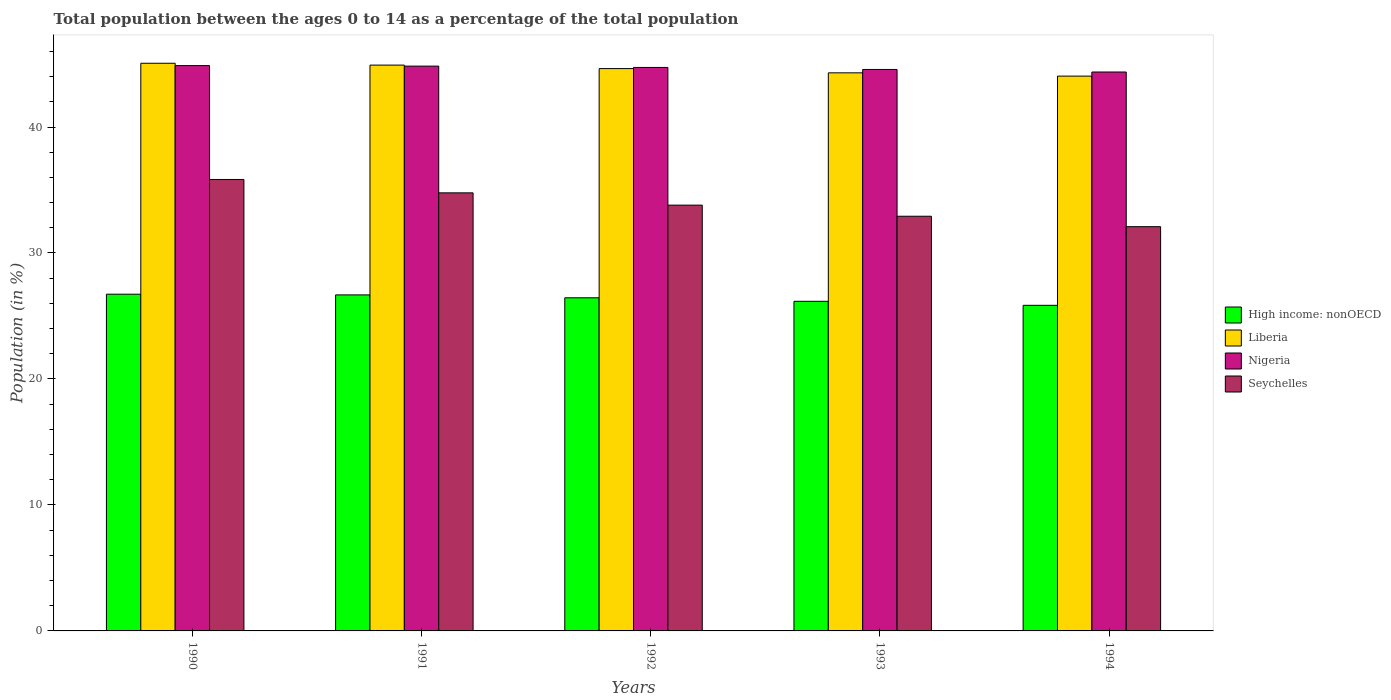How many groups of bars are there?
Keep it short and to the point. 5. Are the number of bars per tick equal to the number of legend labels?
Give a very brief answer. Yes. In how many cases, is the number of bars for a given year not equal to the number of legend labels?
Ensure brevity in your answer.  0. What is the percentage of the population ages 0 to 14 in High income: nonOECD in 1991?
Your answer should be very brief. 26.67. Across all years, what is the maximum percentage of the population ages 0 to 14 in Nigeria?
Ensure brevity in your answer.  44.88. Across all years, what is the minimum percentage of the population ages 0 to 14 in Seychelles?
Provide a succinct answer. 32.09. What is the total percentage of the population ages 0 to 14 in Liberia in the graph?
Your response must be concise. 222.96. What is the difference between the percentage of the population ages 0 to 14 in Seychelles in 1991 and that in 1993?
Offer a terse response. 1.86. What is the difference between the percentage of the population ages 0 to 14 in Seychelles in 1993 and the percentage of the population ages 0 to 14 in High income: nonOECD in 1990?
Ensure brevity in your answer.  6.19. What is the average percentage of the population ages 0 to 14 in Nigeria per year?
Your answer should be compact. 44.68. In the year 1993, what is the difference between the percentage of the population ages 0 to 14 in High income: nonOECD and percentage of the population ages 0 to 14 in Nigeria?
Make the answer very short. -18.4. In how many years, is the percentage of the population ages 0 to 14 in Seychelles greater than 12?
Offer a terse response. 5. What is the ratio of the percentage of the population ages 0 to 14 in Nigeria in 1991 to that in 1994?
Make the answer very short. 1.01. Is the percentage of the population ages 0 to 14 in Nigeria in 1990 less than that in 1993?
Your answer should be compact. No. Is the difference between the percentage of the population ages 0 to 14 in High income: nonOECD in 1991 and 1993 greater than the difference between the percentage of the population ages 0 to 14 in Nigeria in 1991 and 1993?
Offer a terse response. Yes. What is the difference between the highest and the second highest percentage of the population ages 0 to 14 in Seychelles?
Your answer should be very brief. 1.06. What is the difference between the highest and the lowest percentage of the population ages 0 to 14 in High income: nonOECD?
Make the answer very short. 0.88. What does the 3rd bar from the left in 1990 represents?
Your answer should be very brief. Nigeria. What does the 3rd bar from the right in 1994 represents?
Offer a terse response. Liberia. Are all the bars in the graph horizontal?
Make the answer very short. No. What is the difference between two consecutive major ticks on the Y-axis?
Ensure brevity in your answer.  10. Does the graph contain any zero values?
Your answer should be compact. No. Where does the legend appear in the graph?
Your response must be concise. Center right. What is the title of the graph?
Your response must be concise. Total population between the ages 0 to 14 as a percentage of the total population. Does "Upper middle income" appear as one of the legend labels in the graph?
Offer a very short reply. No. What is the label or title of the X-axis?
Provide a short and direct response. Years. What is the Population (in %) in High income: nonOECD in 1990?
Your answer should be compact. 26.73. What is the Population (in %) of Liberia in 1990?
Your answer should be compact. 45.06. What is the Population (in %) of Nigeria in 1990?
Your answer should be compact. 44.88. What is the Population (in %) in Seychelles in 1990?
Offer a terse response. 35.84. What is the Population (in %) of High income: nonOECD in 1991?
Give a very brief answer. 26.67. What is the Population (in %) of Liberia in 1991?
Offer a terse response. 44.92. What is the Population (in %) in Nigeria in 1991?
Your answer should be compact. 44.83. What is the Population (in %) in Seychelles in 1991?
Make the answer very short. 34.77. What is the Population (in %) in High income: nonOECD in 1992?
Offer a terse response. 26.44. What is the Population (in %) in Liberia in 1992?
Your answer should be compact. 44.64. What is the Population (in %) in Nigeria in 1992?
Your answer should be compact. 44.73. What is the Population (in %) in Seychelles in 1992?
Ensure brevity in your answer.  33.8. What is the Population (in %) in High income: nonOECD in 1993?
Make the answer very short. 26.16. What is the Population (in %) in Liberia in 1993?
Keep it short and to the point. 44.3. What is the Population (in %) in Nigeria in 1993?
Your response must be concise. 44.57. What is the Population (in %) in Seychelles in 1993?
Give a very brief answer. 32.92. What is the Population (in %) of High income: nonOECD in 1994?
Offer a very short reply. 25.85. What is the Population (in %) of Liberia in 1994?
Offer a terse response. 44.04. What is the Population (in %) of Nigeria in 1994?
Your answer should be compact. 44.37. What is the Population (in %) in Seychelles in 1994?
Provide a short and direct response. 32.09. Across all years, what is the maximum Population (in %) in High income: nonOECD?
Offer a very short reply. 26.73. Across all years, what is the maximum Population (in %) in Liberia?
Offer a very short reply. 45.06. Across all years, what is the maximum Population (in %) in Nigeria?
Offer a very short reply. 44.88. Across all years, what is the maximum Population (in %) of Seychelles?
Your response must be concise. 35.84. Across all years, what is the minimum Population (in %) in High income: nonOECD?
Offer a very short reply. 25.85. Across all years, what is the minimum Population (in %) of Liberia?
Provide a succinct answer. 44.04. Across all years, what is the minimum Population (in %) of Nigeria?
Provide a short and direct response. 44.37. Across all years, what is the minimum Population (in %) in Seychelles?
Offer a terse response. 32.09. What is the total Population (in %) of High income: nonOECD in the graph?
Offer a very short reply. 131.86. What is the total Population (in %) of Liberia in the graph?
Give a very brief answer. 222.96. What is the total Population (in %) of Nigeria in the graph?
Your answer should be very brief. 223.38. What is the total Population (in %) in Seychelles in the graph?
Offer a terse response. 169.42. What is the difference between the Population (in %) of High income: nonOECD in 1990 and that in 1991?
Provide a short and direct response. 0.06. What is the difference between the Population (in %) of Liberia in 1990 and that in 1991?
Your answer should be compact. 0.15. What is the difference between the Population (in %) in Nigeria in 1990 and that in 1991?
Your response must be concise. 0.04. What is the difference between the Population (in %) of Seychelles in 1990 and that in 1991?
Give a very brief answer. 1.06. What is the difference between the Population (in %) of High income: nonOECD in 1990 and that in 1992?
Your response must be concise. 0.29. What is the difference between the Population (in %) in Liberia in 1990 and that in 1992?
Give a very brief answer. 0.42. What is the difference between the Population (in %) in Nigeria in 1990 and that in 1992?
Provide a short and direct response. 0.15. What is the difference between the Population (in %) of Seychelles in 1990 and that in 1992?
Keep it short and to the point. 2.04. What is the difference between the Population (in %) in High income: nonOECD in 1990 and that in 1993?
Your answer should be very brief. 0.56. What is the difference between the Population (in %) of Liberia in 1990 and that in 1993?
Ensure brevity in your answer.  0.76. What is the difference between the Population (in %) in Nigeria in 1990 and that in 1993?
Ensure brevity in your answer.  0.31. What is the difference between the Population (in %) of Seychelles in 1990 and that in 1993?
Offer a very short reply. 2.92. What is the difference between the Population (in %) in High income: nonOECD in 1990 and that in 1994?
Give a very brief answer. 0.88. What is the difference between the Population (in %) in Liberia in 1990 and that in 1994?
Give a very brief answer. 1.02. What is the difference between the Population (in %) in Nigeria in 1990 and that in 1994?
Offer a terse response. 0.51. What is the difference between the Population (in %) in Seychelles in 1990 and that in 1994?
Keep it short and to the point. 3.75. What is the difference between the Population (in %) of High income: nonOECD in 1991 and that in 1992?
Give a very brief answer. 0.23. What is the difference between the Population (in %) of Liberia in 1991 and that in 1992?
Your response must be concise. 0.28. What is the difference between the Population (in %) in Nigeria in 1991 and that in 1992?
Offer a terse response. 0.11. What is the difference between the Population (in %) of Seychelles in 1991 and that in 1992?
Your answer should be compact. 0.97. What is the difference between the Population (in %) of High income: nonOECD in 1991 and that in 1993?
Provide a succinct answer. 0.51. What is the difference between the Population (in %) of Liberia in 1991 and that in 1993?
Offer a very short reply. 0.61. What is the difference between the Population (in %) in Nigeria in 1991 and that in 1993?
Your response must be concise. 0.27. What is the difference between the Population (in %) in Seychelles in 1991 and that in 1993?
Ensure brevity in your answer.  1.86. What is the difference between the Population (in %) in High income: nonOECD in 1991 and that in 1994?
Offer a terse response. 0.83. What is the difference between the Population (in %) in Liberia in 1991 and that in 1994?
Provide a short and direct response. 0.87. What is the difference between the Population (in %) in Nigeria in 1991 and that in 1994?
Your answer should be compact. 0.47. What is the difference between the Population (in %) in Seychelles in 1991 and that in 1994?
Your response must be concise. 2.68. What is the difference between the Population (in %) in High income: nonOECD in 1992 and that in 1993?
Your answer should be compact. 0.28. What is the difference between the Population (in %) of Liberia in 1992 and that in 1993?
Provide a succinct answer. 0.34. What is the difference between the Population (in %) in Nigeria in 1992 and that in 1993?
Provide a short and direct response. 0.16. What is the difference between the Population (in %) in Seychelles in 1992 and that in 1993?
Provide a short and direct response. 0.88. What is the difference between the Population (in %) of High income: nonOECD in 1992 and that in 1994?
Keep it short and to the point. 0.6. What is the difference between the Population (in %) of Liberia in 1992 and that in 1994?
Make the answer very short. 0.6. What is the difference between the Population (in %) in Nigeria in 1992 and that in 1994?
Ensure brevity in your answer.  0.36. What is the difference between the Population (in %) in Seychelles in 1992 and that in 1994?
Make the answer very short. 1.71. What is the difference between the Population (in %) of High income: nonOECD in 1993 and that in 1994?
Provide a succinct answer. 0.32. What is the difference between the Population (in %) in Liberia in 1993 and that in 1994?
Your answer should be very brief. 0.26. What is the difference between the Population (in %) of Nigeria in 1993 and that in 1994?
Your answer should be very brief. 0.2. What is the difference between the Population (in %) of Seychelles in 1993 and that in 1994?
Your response must be concise. 0.83. What is the difference between the Population (in %) of High income: nonOECD in 1990 and the Population (in %) of Liberia in 1991?
Provide a short and direct response. -18.19. What is the difference between the Population (in %) of High income: nonOECD in 1990 and the Population (in %) of Nigeria in 1991?
Provide a short and direct response. -18.11. What is the difference between the Population (in %) of High income: nonOECD in 1990 and the Population (in %) of Seychelles in 1991?
Keep it short and to the point. -8.04. What is the difference between the Population (in %) in Liberia in 1990 and the Population (in %) in Nigeria in 1991?
Offer a very short reply. 0.23. What is the difference between the Population (in %) in Liberia in 1990 and the Population (in %) in Seychelles in 1991?
Make the answer very short. 10.29. What is the difference between the Population (in %) of Nigeria in 1990 and the Population (in %) of Seychelles in 1991?
Your answer should be very brief. 10.1. What is the difference between the Population (in %) in High income: nonOECD in 1990 and the Population (in %) in Liberia in 1992?
Keep it short and to the point. -17.91. What is the difference between the Population (in %) in High income: nonOECD in 1990 and the Population (in %) in Nigeria in 1992?
Provide a short and direct response. -18. What is the difference between the Population (in %) of High income: nonOECD in 1990 and the Population (in %) of Seychelles in 1992?
Your response must be concise. -7.07. What is the difference between the Population (in %) in Liberia in 1990 and the Population (in %) in Nigeria in 1992?
Provide a short and direct response. 0.33. What is the difference between the Population (in %) of Liberia in 1990 and the Population (in %) of Seychelles in 1992?
Your answer should be very brief. 11.26. What is the difference between the Population (in %) in Nigeria in 1990 and the Population (in %) in Seychelles in 1992?
Provide a succinct answer. 11.08. What is the difference between the Population (in %) of High income: nonOECD in 1990 and the Population (in %) of Liberia in 1993?
Offer a terse response. -17.57. What is the difference between the Population (in %) in High income: nonOECD in 1990 and the Population (in %) in Nigeria in 1993?
Provide a succinct answer. -17.84. What is the difference between the Population (in %) of High income: nonOECD in 1990 and the Population (in %) of Seychelles in 1993?
Your answer should be compact. -6.19. What is the difference between the Population (in %) of Liberia in 1990 and the Population (in %) of Nigeria in 1993?
Provide a succinct answer. 0.49. What is the difference between the Population (in %) in Liberia in 1990 and the Population (in %) in Seychelles in 1993?
Keep it short and to the point. 12.14. What is the difference between the Population (in %) of Nigeria in 1990 and the Population (in %) of Seychelles in 1993?
Your answer should be very brief. 11.96. What is the difference between the Population (in %) of High income: nonOECD in 1990 and the Population (in %) of Liberia in 1994?
Make the answer very short. -17.31. What is the difference between the Population (in %) in High income: nonOECD in 1990 and the Population (in %) in Nigeria in 1994?
Provide a short and direct response. -17.64. What is the difference between the Population (in %) in High income: nonOECD in 1990 and the Population (in %) in Seychelles in 1994?
Your answer should be very brief. -5.36. What is the difference between the Population (in %) in Liberia in 1990 and the Population (in %) in Nigeria in 1994?
Your answer should be very brief. 0.69. What is the difference between the Population (in %) of Liberia in 1990 and the Population (in %) of Seychelles in 1994?
Your answer should be compact. 12.97. What is the difference between the Population (in %) of Nigeria in 1990 and the Population (in %) of Seychelles in 1994?
Your answer should be very brief. 12.79. What is the difference between the Population (in %) in High income: nonOECD in 1991 and the Population (in %) in Liberia in 1992?
Provide a short and direct response. -17.96. What is the difference between the Population (in %) in High income: nonOECD in 1991 and the Population (in %) in Nigeria in 1992?
Keep it short and to the point. -18.05. What is the difference between the Population (in %) of High income: nonOECD in 1991 and the Population (in %) of Seychelles in 1992?
Offer a very short reply. -7.13. What is the difference between the Population (in %) of Liberia in 1991 and the Population (in %) of Nigeria in 1992?
Provide a short and direct response. 0.19. What is the difference between the Population (in %) of Liberia in 1991 and the Population (in %) of Seychelles in 1992?
Provide a succinct answer. 11.12. What is the difference between the Population (in %) of Nigeria in 1991 and the Population (in %) of Seychelles in 1992?
Make the answer very short. 11.04. What is the difference between the Population (in %) in High income: nonOECD in 1991 and the Population (in %) in Liberia in 1993?
Offer a very short reply. -17.63. What is the difference between the Population (in %) of High income: nonOECD in 1991 and the Population (in %) of Nigeria in 1993?
Your answer should be compact. -17.89. What is the difference between the Population (in %) in High income: nonOECD in 1991 and the Population (in %) in Seychelles in 1993?
Give a very brief answer. -6.24. What is the difference between the Population (in %) of Liberia in 1991 and the Population (in %) of Nigeria in 1993?
Provide a succinct answer. 0.35. What is the difference between the Population (in %) in Liberia in 1991 and the Population (in %) in Seychelles in 1993?
Provide a short and direct response. 12. What is the difference between the Population (in %) in Nigeria in 1991 and the Population (in %) in Seychelles in 1993?
Your answer should be very brief. 11.92. What is the difference between the Population (in %) in High income: nonOECD in 1991 and the Population (in %) in Liberia in 1994?
Give a very brief answer. -17.37. What is the difference between the Population (in %) in High income: nonOECD in 1991 and the Population (in %) in Nigeria in 1994?
Ensure brevity in your answer.  -17.69. What is the difference between the Population (in %) of High income: nonOECD in 1991 and the Population (in %) of Seychelles in 1994?
Keep it short and to the point. -5.42. What is the difference between the Population (in %) of Liberia in 1991 and the Population (in %) of Nigeria in 1994?
Your response must be concise. 0.55. What is the difference between the Population (in %) in Liberia in 1991 and the Population (in %) in Seychelles in 1994?
Keep it short and to the point. 12.83. What is the difference between the Population (in %) of Nigeria in 1991 and the Population (in %) of Seychelles in 1994?
Your answer should be compact. 12.75. What is the difference between the Population (in %) in High income: nonOECD in 1992 and the Population (in %) in Liberia in 1993?
Your response must be concise. -17.86. What is the difference between the Population (in %) of High income: nonOECD in 1992 and the Population (in %) of Nigeria in 1993?
Your answer should be compact. -18.12. What is the difference between the Population (in %) of High income: nonOECD in 1992 and the Population (in %) of Seychelles in 1993?
Provide a short and direct response. -6.47. What is the difference between the Population (in %) in Liberia in 1992 and the Population (in %) in Nigeria in 1993?
Your response must be concise. 0.07. What is the difference between the Population (in %) of Liberia in 1992 and the Population (in %) of Seychelles in 1993?
Your response must be concise. 11.72. What is the difference between the Population (in %) of Nigeria in 1992 and the Population (in %) of Seychelles in 1993?
Your response must be concise. 11.81. What is the difference between the Population (in %) in High income: nonOECD in 1992 and the Population (in %) in Liberia in 1994?
Ensure brevity in your answer.  -17.6. What is the difference between the Population (in %) of High income: nonOECD in 1992 and the Population (in %) of Nigeria in 1994?
Give a very brief answer. -17.92. What is the difference between the Population (in %) of High income: nonOECD in 1992 and the Population (in %) of Seychelles in 1994?
Provide a short and direct response. -5.64. What is the difference between the Population (in %) in Liberia in 1992 and the Population (in %) in Nigeria in 1994?
Provide a succinct answer. 0.27. What is the difference between the Population (in %) in Liberia in 1992 and the Population (in %) in Seychelles in 1994?
Your response must be concise. 12.55. What is the difference between the Population (in %) of Nigeria in 1992 and the Population (in %) of Seychelles in 1994?
Your response must be concise. 12.64. What is the difference between the Population (in %) of High income: nonOECD in 1993 and the Population (in %) of Liberia in 1994?
Your answer should be compact. -17.88. What is the difference between the Population (in %) in High income: nonOECD in 1993 and the Population (in %) in Nigeria in 1994?
Ensure brevity in your answer.  -18.2. What is the difference between the Population (in %) in High income: nonOECD in 1993 and the Population (in %) in Seychelles in 1994?
Make the answer very short. -5.92. What is the difference between the Population (in %) of Liberia in 1993 and the Population (in %) of Nigeria in 1994?
Provide a short and direct response. -0.07. What is the difference between the Population (in %) of Liberia in 1993 and the Population (in %) of Seychelles in 1994?
Your answer should be very brief. 12.21. What is the difference between the Population (in %) of Nigeria in 1993 and the Population (in %) of Seychelles in 1994?
Provide a short and direct response. 12.48. What is the average Population (in %) in High income: nonOECD per year?
Your response must be concise. 26.37. What is the average Population (in %) of Liberia per year?
Ensure brevity in your answer.  44.59. What is the average Population (in %) in Nigeria per year?
Your response must be concise. 44.68. What is the average Population (in %) in Seychelles per year?
Provide a succinct answer. 33.88. In the year 1990, what is the difference between the Population (in %) in High income: nonOECD and Population (in %) in Liberia?
Make the answer very short. -18.33. In the year 1990, what is the difference between the Population (in %) in High income: nonOECD and Population (in %) in Nigeria?
Give a very brief answer. -18.15. In the year 1990, what is the difference between the Population (in %) of High income: nonOECD and Population (in %) of Seychelles?
Your answer should be very brief. -9.11. In the year 1990, what is the difference between the Population (in %) of Liberia and Population (in %) of Nigeria?
Your response must be concise. 0.19. In the year 1990, what is the difference between the Population (in %) of Liberia and Population (in %) of Seychelles?
Offer a terse response. 9.23. In the year 1990, what is the difference between the Population (in %) in Nigeria and Population (in %) in Seychelles?
Offer a very short reply. 9.04. In the year 1991, what is the difference between the Population (in %) in High income: nonOECD and Population (in %) in Liberia?
Ensure brevity in your answer.  -18.24. In the year 1991, what is the difference between the Population (in %) in High income: nonOECD and Population (in %) in Nigeria?
Provide a short and direct response. -18.16. In the year 1991, what is the difference between the Population (in %) in High income: nonOECD and Population (in %) in Seychelles?
Your response must be concise. -8.1. In the year 1991, what is the difference between the Population (in %) of Liberia and Population (in %) of Nigeria?
Provide a short and direct response. 0.08. In the year 1991, what is the difference between the Population (in %) in Liberia and Population (in %) in Seychelles?
Your answer should be compact. 10.14. In the year 1991, what is the difference between the Population (in %) of Nigeria and Population (in %) of Seychelles?
Give a very brief answer. 10.06. In the year 1992, what is the difference between the Population (in %) in High income: nonOECD and Population (in %) in Liberia?
Offer a terse response. -18.19. In the year 1992, what is the difference between the Population (in %) of High income: nonOECD and Population (in %) of Nigeria?
Ensure brevity in your answer.  -18.28. In the year 1992, what is the difference between the Population (in %) of High income: nonOECD and Population (in %) of Seychelles?
Keep it short and to the point. -7.35. In the year 1992, what is the difference between the Population (in %) in Liberia and Population (in %) in Nigeria?
Ensure brevity in your answer.  -0.09. In the year 1992, what is the difference between the Population (in %) of Liberia and Population (in %) of Seychelles?
Ensure brevity in your answer.  10.84. In the year 1992, what is the difference between the Population (in %) of Nigeria and Population (in %) of Seychelles?
Offer a very short reply. 10.93. In the year 1993, what is the difference between the Population (in %) of High income: nonOECD and Population (in %) of Liberia?
Give a very brief answer. -18.14. In the year 1993, what is the difference between the Population (in %) in High income: nonOECD and Population (in %) in Nigeria?
Give a very brief answer. -18.4. In the year 1993, what is the difference between the Population (in %) in High income: nonOECD and Population (in %) in Seychelles?
Provide a short and direct response. -6.75. In the year 1993, what is the difference between the Population (in %) in Liberia and Population (in %) in Nigeria?
Your answer should be very brief. -0.27. In the year 1993, what is the difference between the Population (in %) in Liberia and Population (in %) in Seychelles?
Offer a very short reply. 11.38. In the year 1993, what is the difference between the Population (in %) in Nigeria and Population (in %) in Seychelles?
Offer a very short reply. 11.65. In the year 1994, what is the difference between the Population (in %) of High income: nonOECD and Population (in %) of Liberia?
Provide a succinct answer. -18.19. In the year 1994, what is the difference between the Population (in %) in High income: nonOECD and Population (in %) in Nigeria?
Your answer should be very brief. -18.52. In the year 1994, what is the difference between the Population (in %) of High income: nonOECD and Population (in %) of Seychelles?
Your answer should be compact. -6.24. In the year 1994, what is the difference between the Population (in %) in Liberia and Population (in %) in Nigeria?
Provide a short and direct response. -0.33. In the year 1994, what is the difference between the Population (in %) of Liberia and Population (in %) of Seychelles?
Offer a terse response. 11.95. In the year 1994, what is the difference between the Population (in %) in Nigeria and Population (in %) in Seychelles?
Provide a succinct answer. 12.28. What is the ratio of the Population (in %) of Liberia in 1990 to that in 1991?
Your response must be concise. 1. What is the ratio of the Population (in %) in Seychelles in 1990 to that in 1991?
Your answer should be very brief. 1.03. What is the ratio of the Population (in %) in High income: nonOECD in 1990 to that in 1992?
Your response must be concise. 1.01. What is the ratio of the Population (in %) of Liberia in 1990 to that in 1992?
Your answer should be compact. 1.01. What is the ratio of the Population (in %) of Seychelles in 1990 to that in 1992?
Offer a very short reply. 1.06. What is the ratio of the Population (in %) of High income: nonOECD in 1990 to that in 1993?
Give a very brief answer. 1.02. What is the ratio of the Population (in %) of Liberia in 1990 to that in 1993?
Offer a very short reply. 1.02. What is the ratio of the Population (in %) of Nigeria in 1990 to that in 1993?
Make the answer very short. 1.01. What is the ratio of the Population (in %) of Seychelles in 1990 to that in 1993?
Offer a very short reply. 1.09. What is the ratio of the Population (in %) of High income: nonOECD in 1990 to that in 1994?
Provide a short and direct response. 1.03. What is the ratio of the Population (in %) of Liberia in 1990 to that in 1994?
Provide a short and direct response. 1.02. What is the ratio of the Population (in %) of Nigeria in 1990 to that in 1994?
Offer a very short reply. 1.01. What is the ratio of the Population (in %) of Seychelles in 1990 to that in 1994?
Offer a very short reply. 1.12. What is the ratio of the Population (in %) in High income: nonOECD in 1991 to that in 1992?
Make the answer very short. 1.01. What is the ratio of the Population (in %) in Liberia in 1991 to that in 1992?
Your response must be concise. 1.01. What is the ratio of the Population (in %) of Nigeria in 1991 to that in 1992?
Give a very brief answer. 1. What is the ratio of the Population (in %) of Seychelles in 1991 to that in 1992?
Provide a short and direct response. 1.03. What is the ratio of the Population (in %) in High income: nonOECD in 1991 to that in 1993?
Offer a terse response. 1.02. What is the ratio of the Population (in %) of Liberia in 1991 to that in 1993?
Your answer should be very brief. 1.01. What is the ratio of the Population (in %) in Nigeria in 1991 to that in 1993?
Your answer should be very brief. 1.01. What is the ratio of the Population (in %) in Seychelles in 1991 to that in 1993?
Your response must be concise. 1.06. What is the ratio of the Population (in %) in High income: nonOECD in 1991 to that in 1994?
Keep it short and to the point. 1.03. What is the ratio of the Population (in %) of Liberia in 1991 to that in 1994?
Make the answer very short. 1.02. What is the ratio of the Population (in %) in Nigeria in 1991 to that in 1994?
Provide a short and direct response. 1.01. What is the ratio of the Population (in %) in Seychelles in 1991 to that in 1994?
Offer a terse response. 1.08. What is the ratio of the Population (in %) in High income: nonOECD in 1992 to that in 1993?
Provide a succinct answer. 1.01. What is the ratio of the Population (in %) in Liberia in 1992 to that in 1993?
Your answer should be compact. 1.01. What is the ratio of the Population (in %) of Seychelles in 1992 to that in 1993?
Your answer should be compact. 1.03. What is the ratio of the Population (in %) in High income: nonOECD in 1992 to that in 1994?
Ensure brevity in your answer.  1.02. What is the ratio of the Population (in %) of Liberia in 1992 to that in 1994?
Provide a short and direct response. 1.01. What is the ratio of the Population (in %) of Nigeria in 1992 to that in 1994?
Your answer should be compact. 1.01. What is the ratio of the Population (in %) in Seychelles in 1992 to that in 1994?
Ensure brevity in your answer.  1.05. What is the ratio of the Population (in %) in High income: nonOECD in 1993 to that in 1994?
Offer a terse response. 1.01. What is the ratio of the Population (in %) of Liberia in 1993 to that in 1994?
Offer a terse response. 1.01. What is the ratio of the Population (in %) in Nigeria in 1993 to that in 1994?
Your answer should be very brief. 1. What is the ratio of the Population (in %) in Seychelles in 1993 to that in 1994?
Offer a terse response. 1.03. What is the difference between the highest and the second highest Population (in %) of High income: nonOECD?
Make the answer very short. 0.06. What is the difference between the highest and the second highest Population (in %) of Liberia?
Your answer should be very brief. 0.15. What is the difference between the highest and the second highest Population (in %) in Nigeria?
Offer a terse response. 0.04. What is the difference between the highest and the second highest Population (in %) in Seychelles?
Provide a succinct answer. 1.06. What is the difference between the highest and the lowest Population (in %) of High income: nonOECD?
Provide a succinct answer. 0.88. What is the difference between the highest and the lowest Population (in %) in Liberia?
Offer a very short reply. 1.02. What is the difference between the highest and the lowest Population (in %) of Nigeria?
Your answer should be very brief. 0.51. What is the difference between the highest and the lowest Population (in %) in Seychelles?
Give a very brief answer. 3.75. 